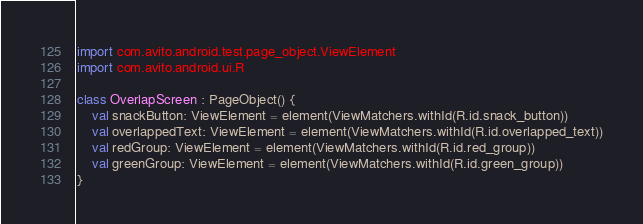Convert code to text. <code><loc_0><loc_0><loc_500><loc_500><_Kotlin_>import com.avito.android.test.page_object.ViewElement
import com.avito.android.ui.R

class OverlapScreen : PageObject() {
    val snackButton: ViewElement = element(ViewMatchers.withId(R.id.snack_button))
    val overlappedText: ViewElement = element(ViewMatchers.withId(R.id.overlapped_text))
    val redGroup: ViewElement = element(ViewMatchers.withId(R.id.red_group))
    val greenGroup: ViewElement = element(ViewMatchers.withId(R.id.green_group))
}</code> 